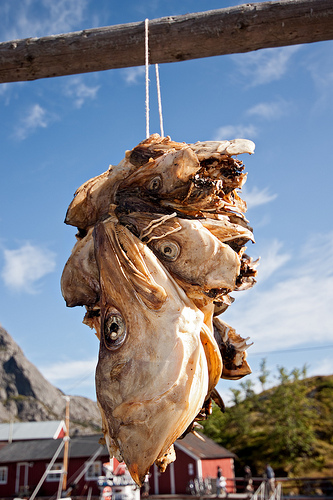<image>
Can you confirm if the fish heads is in front of the sky? Yes. The fish heads is positioned in front of the sky, appearing closer to the camera viewpoint. 